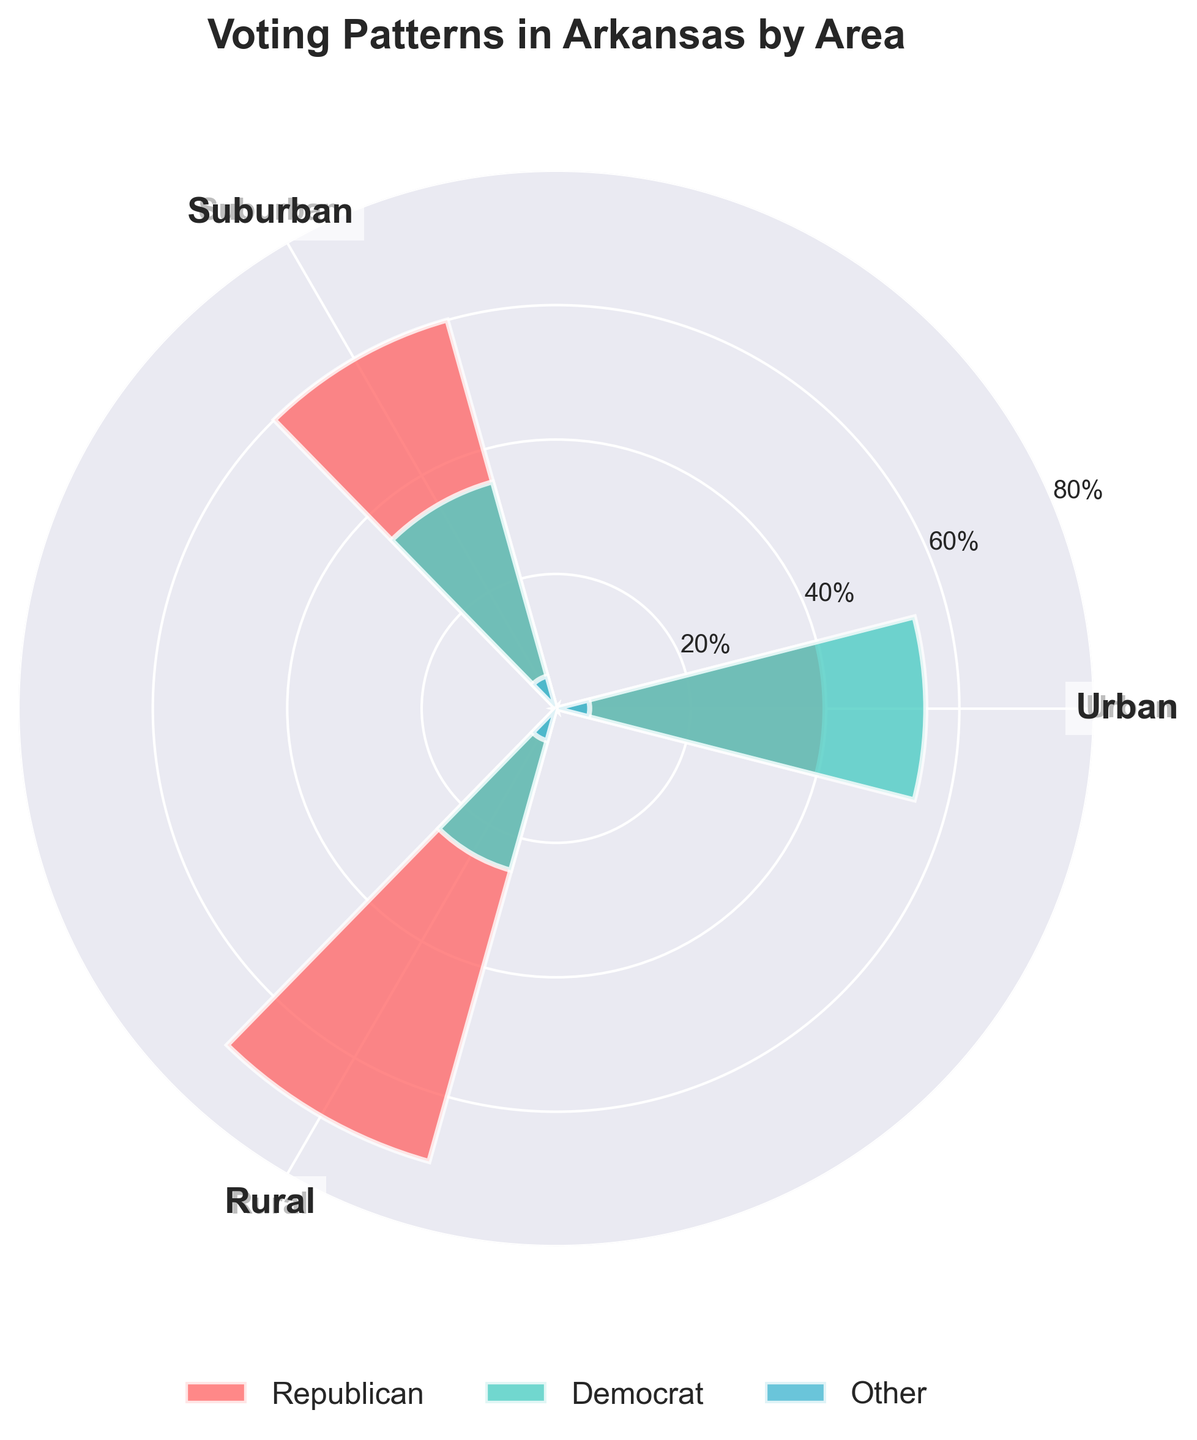What is the title of the figure? The title is displayed at the top center of the plot in bold font.
Answer: Voting Patterns in Arkansas by Area Which area has the highest percentage of Republican voters? The plot shows three areas with different colors representing each party. The segment with the highest value for Republican is in the rural area.
Answer: Yell What is the percentage difference between Republican and Democrat voters in Pulaski? The bar for Republican shows 40% and the bar for Democrat shows 55%. The difference is calculated by subtracting 40% from 55%.
Answer: 15% How do the other parties fare across the different areas? The segments for the 'Other' category in all three areas are the smallest, consistently at 5% as shown on the plot.
Answer: 5% in all areas Which area has the smallest percentage of Democrat voters? By comparing the segments labeled 'Democrat' in all three areas, the smallest percentage is found in the rural area.
Answer: Yell What is the total percentage of Republican voters in Benton and Yell counties combined? The Republican percentage in Benton is 60% and in Yell is 70%. Adding these percentages gives the total.
Answer: 130% How does the percentage of Democrat voters in suburban areas compare to urban areas? Comparing the segments labeled 'Democrat' in suburban and urban areas: suburban (35%) and urban (55%).
Answer: 20% higher in urban What is the average percentage of Democrat voters across all three areas? The Democrat percentages are 55% in urban, 35% in suburban, and 25% in rural. Adding these (55+35+25 = 115) and dividing by 3 gives the average.
Answer: 38.33% In which area is the percentage of Republican voters greater than the combined percentage of Democrat and Other voters? By comparing the Republican segment values to the combined Democrat and Other values: rural (70%) is greater than Democrat (25%) + Other (5%).
Answer: Yell What is the common percentage across all three areas for the 'Other' party? The 'Other' category consistently shows a segment of 5% across urban, suburban, and rural areas.
Answer: 5% 